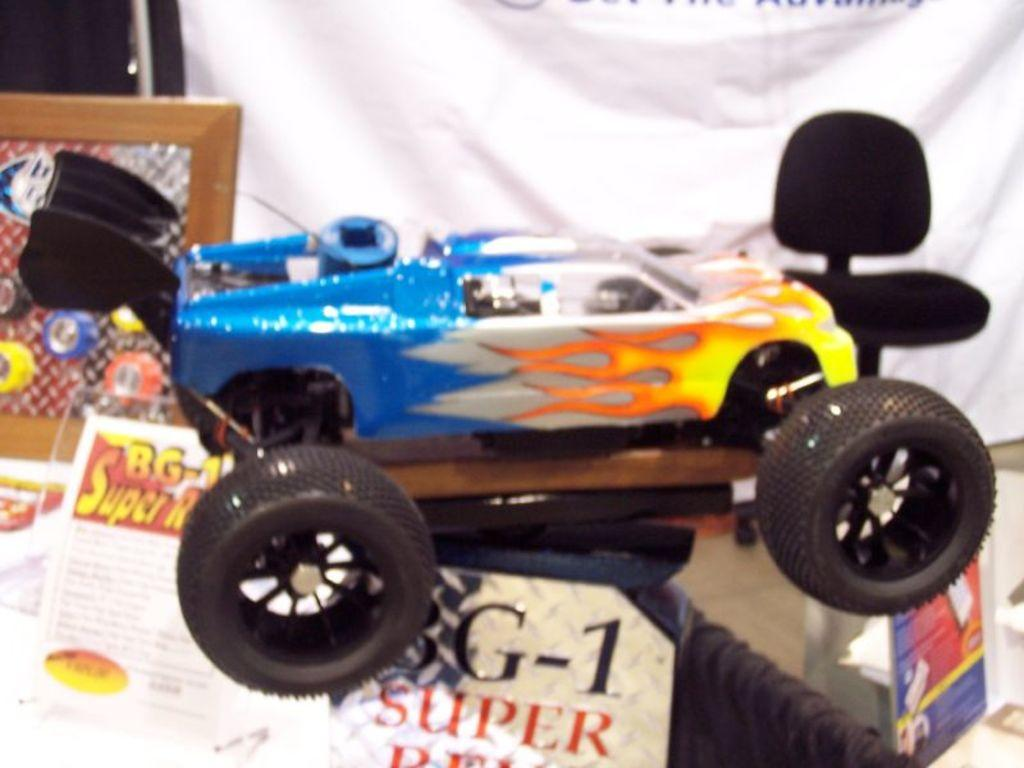What type of object is in the image? There is a toy vehicle in the image. What colors can be seen on the toy vehicle? The toy vehicle has blue, yellow, white, and orange colors. What other items are present in the image besides the toy vehicle? There are pamphlets, a frame, and a white color banner in the image. How does the size of the rock affect the heat distribution in the image? There is no rock present in the image, so it is not possible to determine how its size would affect heat distribution. 